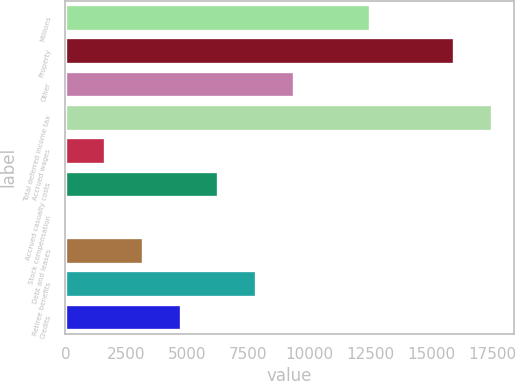<chart> <loc_0><loc_0><loc_500><loc_500><bar_chart><fcel>Millions<fcel>Property<fcel>Other<fcel>Total deferred income tax<fcel>Accrued wages<fcel>Accrued casualty costs<fcel>Stock compensation<fcel>Debt and leases<fcel>Retiree benefits<fcel>Credits<nl><fcel>12481<fcel>15954.5<fcel>9378<fcel>17506<fcel>1620.5<fcel>6275<fcel>69<fcel>3172<fcel>7826.5<fcel>4723.5<nl></chart> 